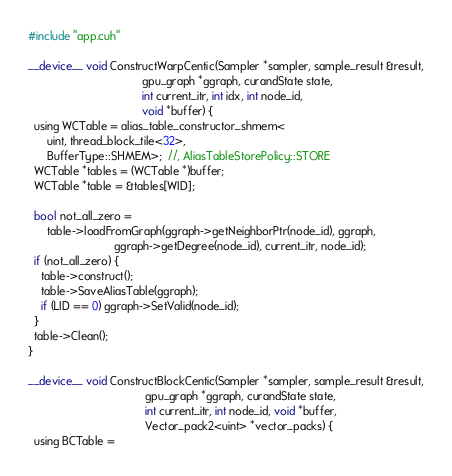<code> <loc_0><loc_0><loc_500><loc_500><_Cuda_>#include "app.cuh"

__device__ void ConstructWarpCentic(Sampler *sampler, sample_result &result,
                                    gpu_graph *ggraph, curandState state,
                                    int current_itr, int idx, int node_id,
                                    void *buffer) {
  using WCTable = alias_table_constructor_shmem<
      uint, thread_block_tile<32>,
      BufferType::SHMEM>;  //, AliasTableStorePolicy::STORE
  WCTable *tables = (WCTable *)buffer;
  WCTable *table = &tables[WID];

  bool not_all_zero =
      table->loadFromGraph(ggraph->getNeighborPtr(node_id), ggraph,
                           ggraph->getDegree(node_id), current_itr, node_id);
  if (not_all_zero) {
    table->construct();
    table->SaveAliasTable(ggraph);
    if (LID == 0) ggraph->SetValid(node_id);
  }
  table->Clean();
}

__device__ void ConstructBlockCentic(Sampler *sampler, sample_result &result,
                                     gpu_graph *ggraph, curandState state,
                                     int current_itr, int node_id, void *buffer,
                                     Vector_pack2<uint> *vector_packs) {
  using BCTable =</code> 